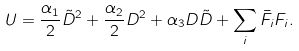Convert formula to latex. <formula><loc_0><loc_0><loc_500><loc_500>U = \frac { \alpha _ { 1 } } { 2 } \tilde { D } ^ { 2 } + \frac { \alpha _ { 2 } } { 2 } D ^ { 2 } + \alpha _ { 3 } D \tilde { D } + \sum _ { i } \bar { F } _ { i } F _ { i } .</formula> 